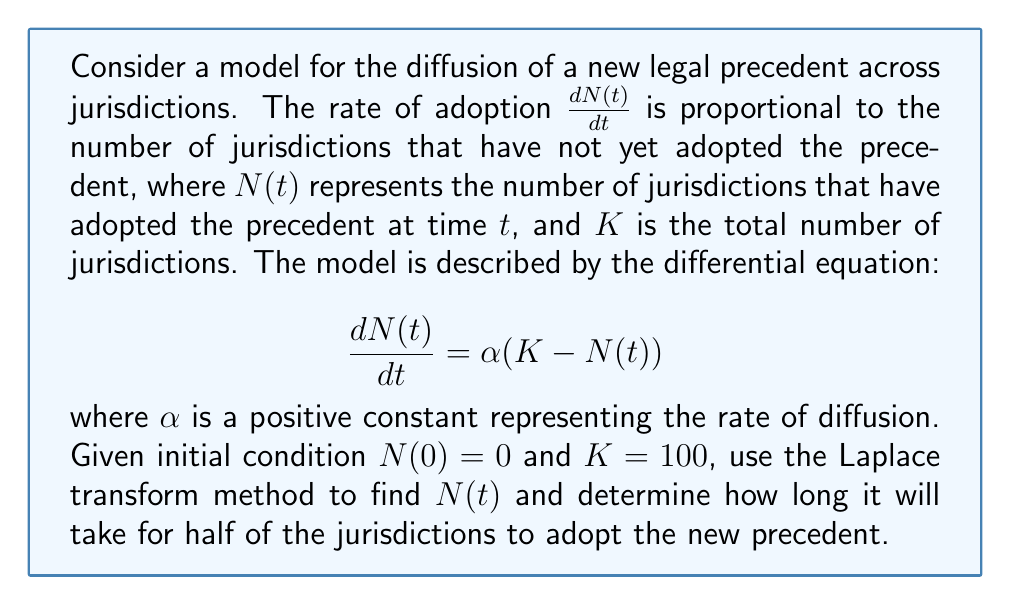Can you solve this math problem? Let's solve this step-by-step using the Laplace transform method:

1) Take the Laplace transform of both sides of the equation:
   $$\mathcal{L}\left\{\frac{dN(t)}{dt}\right\} = \mathcal{L}\{\alpha(K - N(t))\}$$

2) Using the linearity property and the fact that $\mathcal{L}\{K\} = \frac{K}{s}$:
   $$s\mathcal{L}\{N(t)\} - N(0) = \alpha K \cdot \frac{1}{s} - \alpha \mathcal{L}\{N(t)\}$$

3) Let $\mathcal{L}\{N(t)\} = F(s)$. Substituting $N(0) = 0$ and rearranging:
   $$sF(s) = \frac{\alpha K}{s} - \alpha F(s)$$
   $$(s + \alpha)F(s) = \frac{\alpha K}{s}$$

4) Solve for $F(s)$:
   $$F(s) = \frac{\alpha K}{s(s + \alpha)}$$

5) Decompose into partial fractions:
   $$F(s) = \frac{K}{s} - \frac{K}{s + \alpha}$$

6) Take the inverse Laplace transform:
   $$N(t) = K - Ke^{-\alpha t}$$

7) To find when half of the jurisdictions have adopted the precedent, set $N(t) = \frac{K}{2}$:
   $$\frac{K}{2} = K - Ke^{-\alpha t}$$
   $$\frac{1}{2} = 1 - e^{-\alpha t}$$
   $$e^{-\alpha t} = \frac{1}{2}$$

8) Solve for $t$:
   $$-\alpha t = \ln(\frac{1}{2})$$
   $$t = -\frac{\ln(\frac{1}{2})}{\alpha} = \frac{\ln(2)}{\alpha}$$

Therefore, the time it takes for half of the jurisdictions to adopt the new precedent is $\frac{\ln(2)}{\alpha}$.
Answer: $N(t) = 100(1 - e^{-\alpha t})$; Time for half adoption: $\frac{\ln(2)}{\alpha}$ 